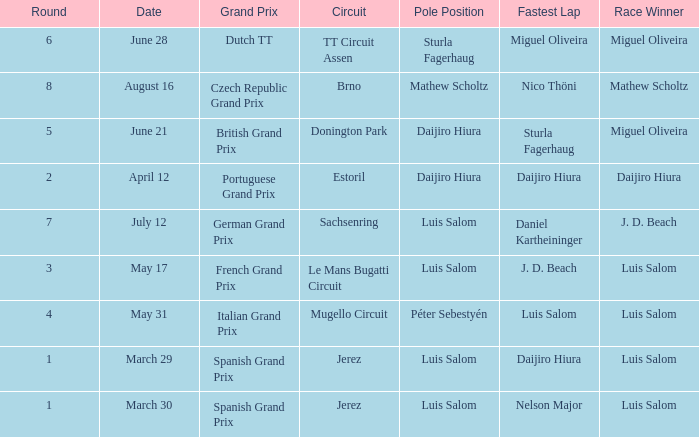Who had the fastest lap in the Dutch TT Grand Prix?  Miguel Oliveira. 